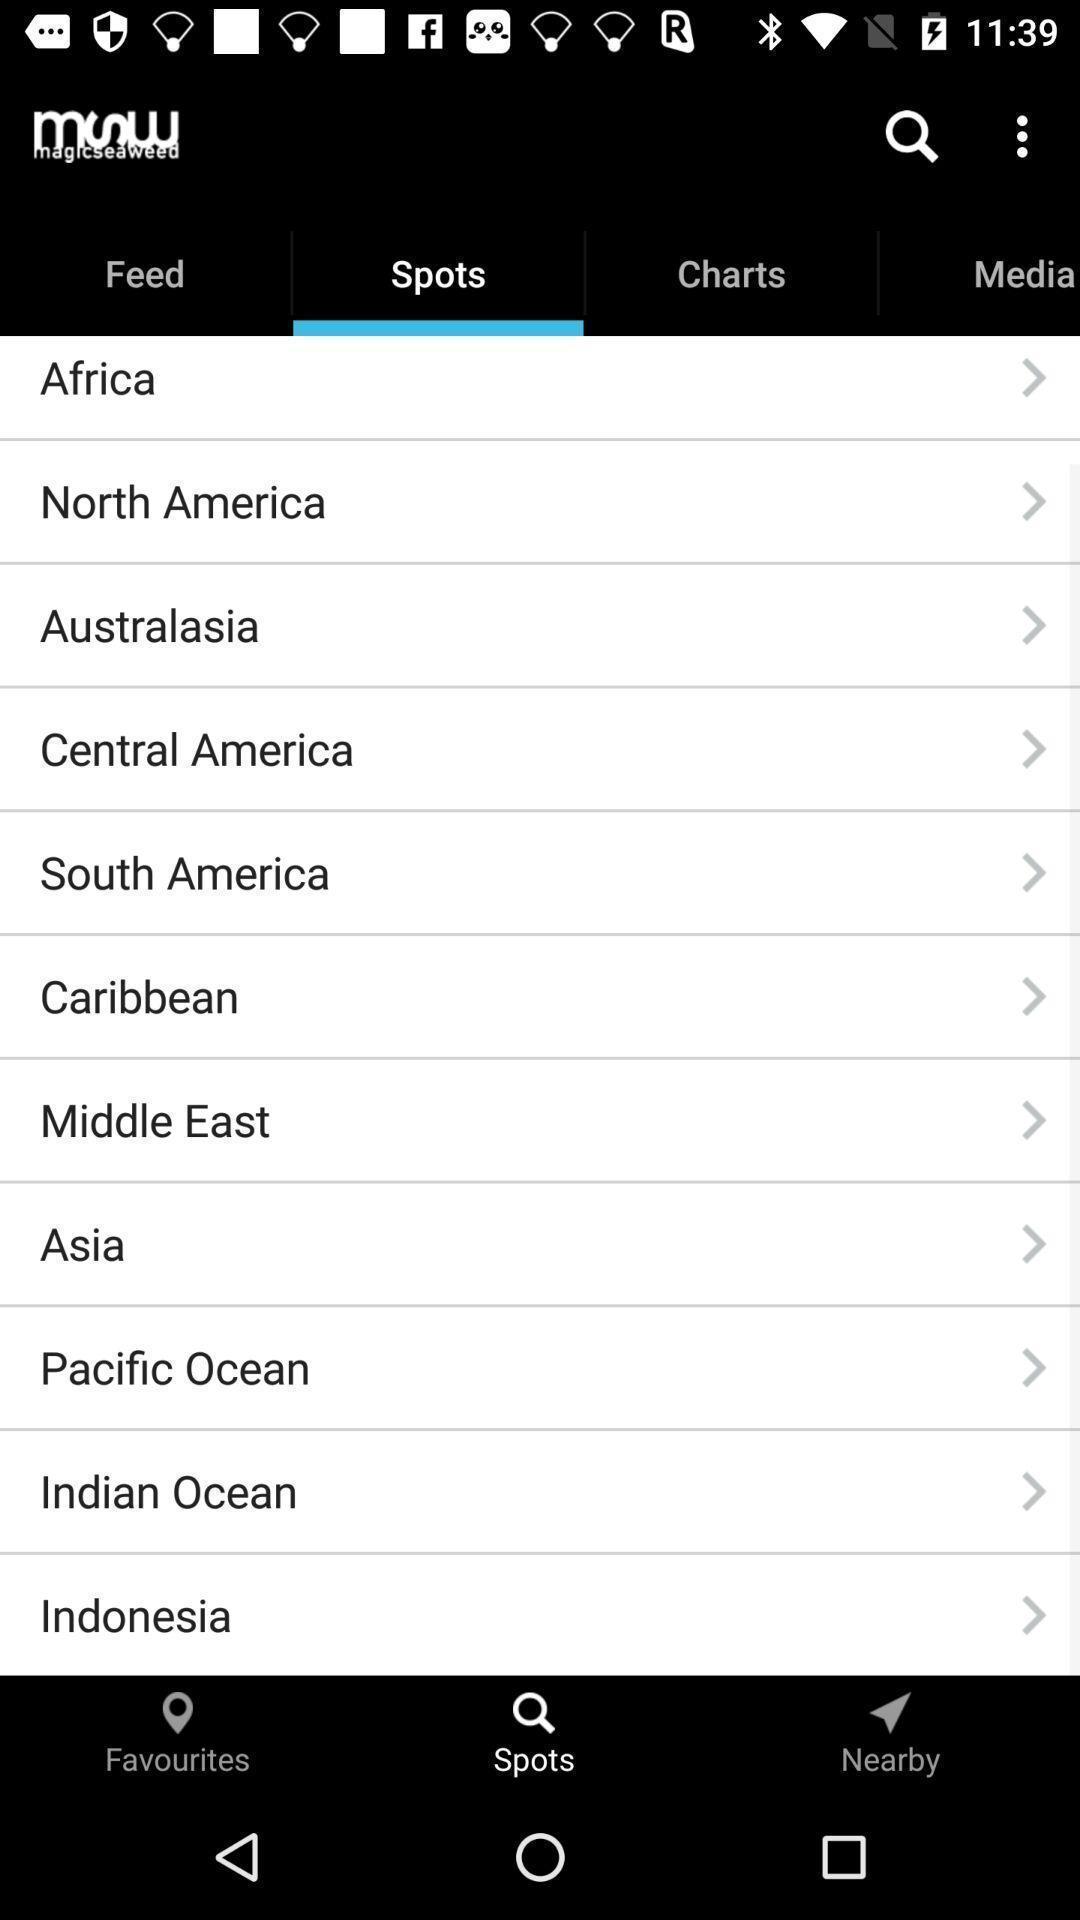Give me a summary of this screen capture. Social app showing list of spots. 